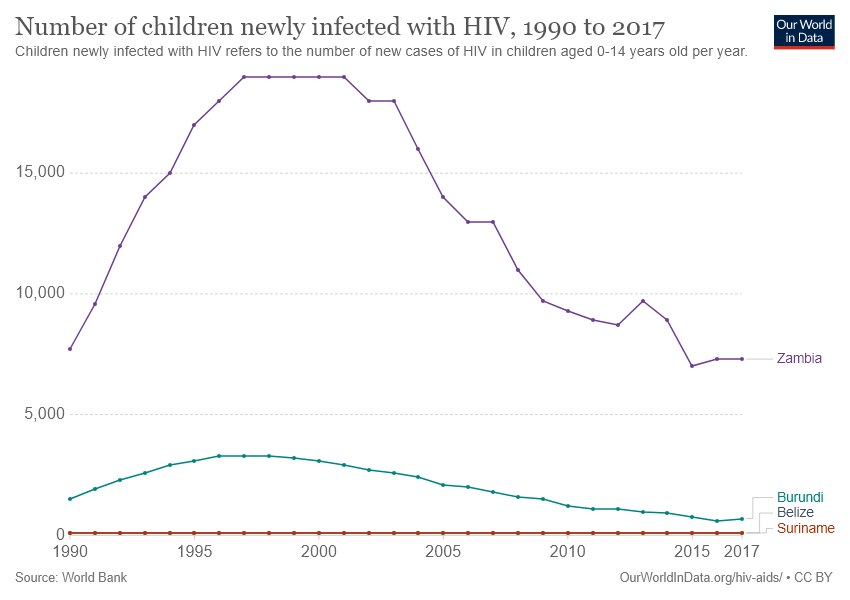Draw attention to some important aspects in this diagram. The number of newly infected children with HIV was higher in Zambia than in Belize over the years. In the year 2015 and 2017, the line representing Burundi experienced its highest dip. 